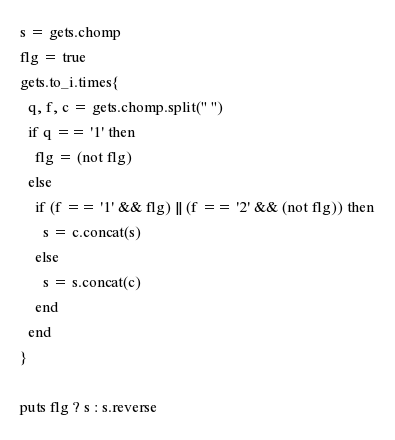Convert code to text. <code><loc_0><loc_0><loc_500><loc_500><_Ruby_>s = gets.chomp
flg = true
gets.to_i.times{
  q, f, c = gets.chomp.split(" ")
  if q == '1' then
    flg = (not flg)
  else
    if (f == '1' && flg) || (f == '2' && (not flg)) then
      s = c.concat(s)
    else
      s = s.concat(c)
    end
  end
}

puts flg ? s : s.reverse
</code> 